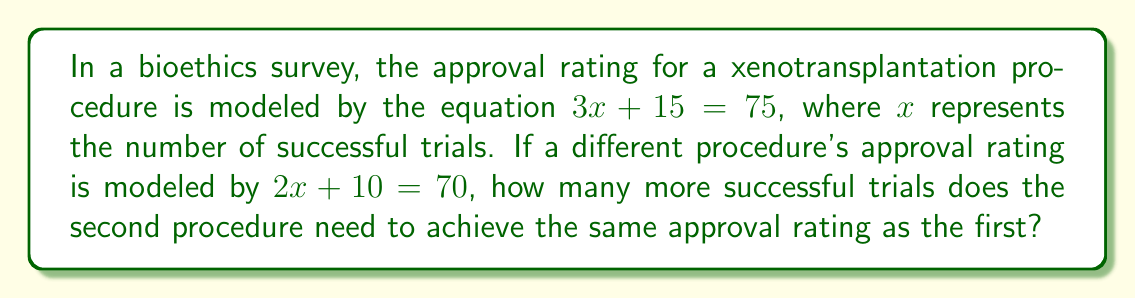Provide a solution to this math problem. 1. Solve for $x$ in the first equation:
   $3x + 15 = 75$
   $3x = 60$
   $x = 20$
   The first procedure needs 20 successful trials to reach a 75% approval rating.

2. Solve for $x$ in the second equation:
   $2x + 10 = 70$
   $2x = 60$
   $x = 30$
   The second procedure needs 30 successful trials to reach a 70% approval rating.

3. To reach the same approval rating as the first procedure (75%), we need to solve:
   $2x + 10 = 75$
   $2x = 65$
   $x = 32.5$

4. Calculate the difference in trials needed:
   $32.5 - 30 = 2.5$

Therefore, the second procedure needs 2.5 more successful trials to achieve the same approval rating as the first procedure.
Answer: 2.5 trials 